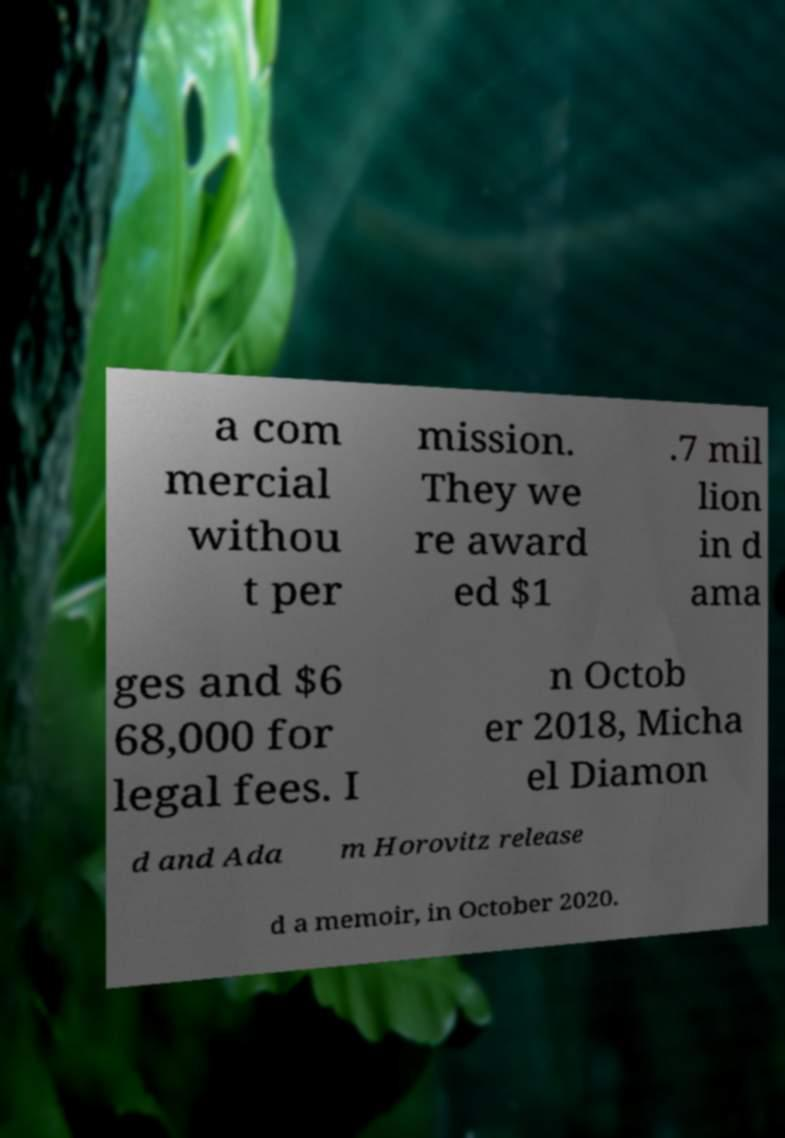Please identify and transcribe the text found in this image. a com mercial withou t per mission. They we re award ed $1 .7 mil lion in d ama ges and $6 68,000 for legal fees. I n Octob er 2018, Micha el Diamon d and Ada m Horovitz release d a memoir, in October 2020. 